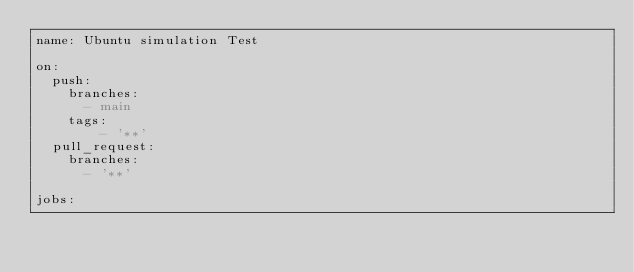<code> <loc_0><loc_0><loc_500><loc_500><_YAML_>name: Ubuntu simulation Test

on:
  push:
    branches:
      - main
    tags:
        - '**'
  pull_request:
    branches:
      - '**'

jobs:</code> 